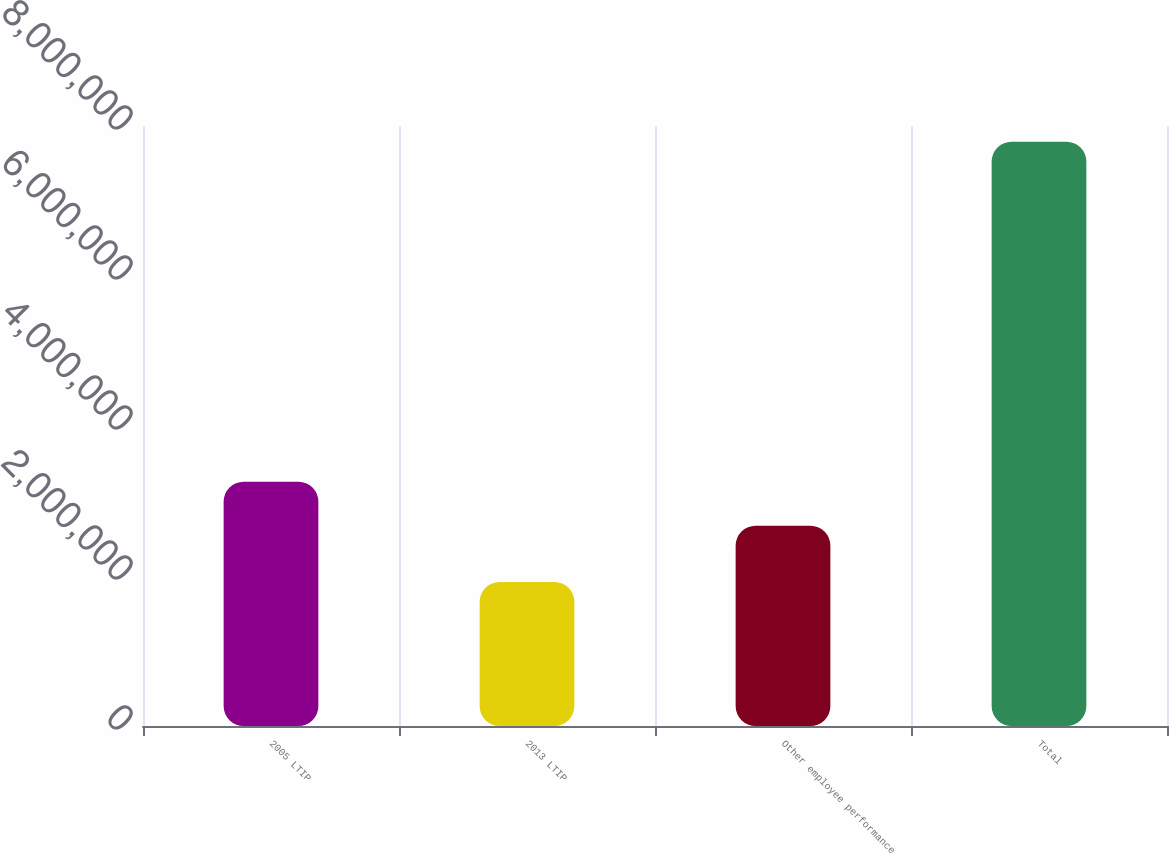Convert chart to OTSL. <chart><loc_0><loc_0><loc_500><loc_500><bar_chart><fcel>2005 LTIP<fcel>2013 LTIP<fcel>Other employee performance<fcel>Total<nl><fcel>3.25705e+06<fcel>1.92e+06<fcel>2.67e+06<fcel>7.7905e+06<nl></chart> 